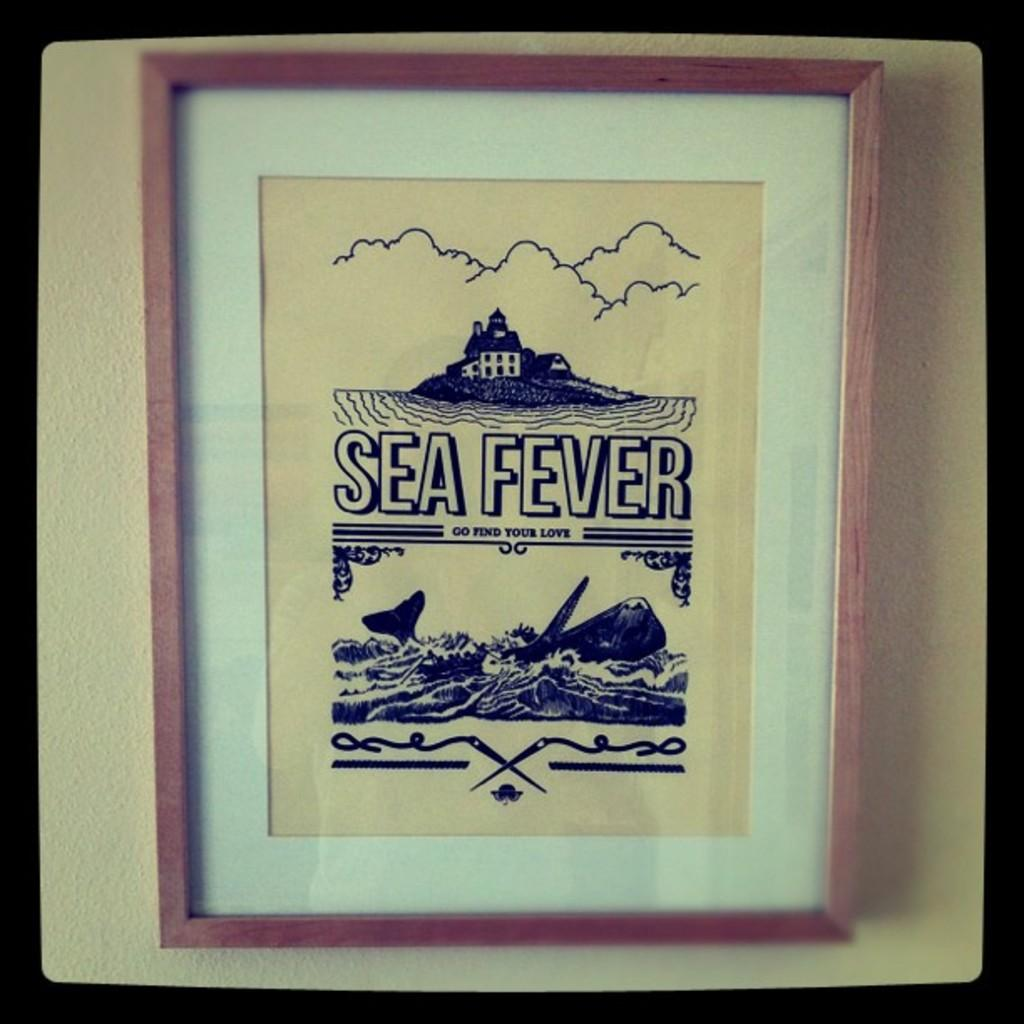Provide a one-sentence caption for the provided image. A framed and matted picture reads Sea Fever and Go find your love. 